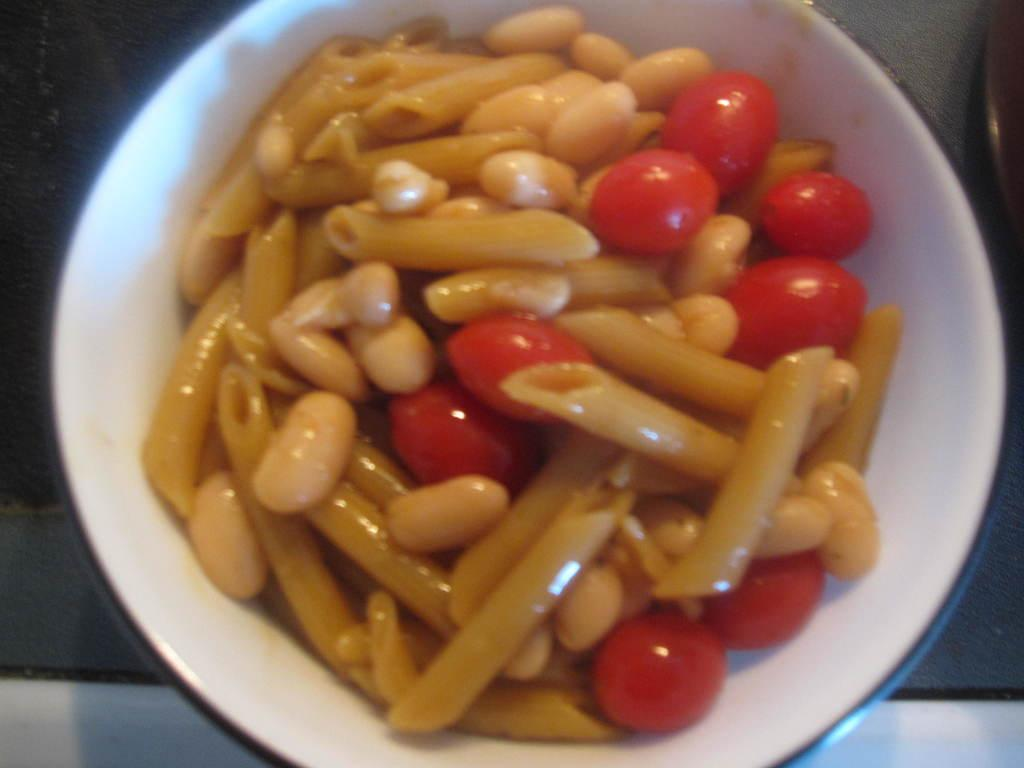What type of food can be seen in the image? There is a group of cherries in the image. How are the cherries arranged in the image? The cherries are placed in a bowl. What type of reaction can be seen in the image? There is no reaction visible in the image; it only shows a group of cherries in a bowl. 